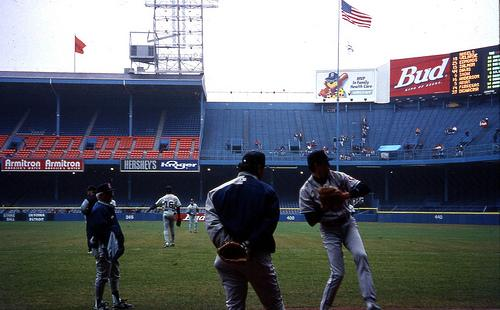What are some prominent advertisements shown in the image? Hershey's, Bud, and Armitron are some of the prominent advertisements displayed. Mention any number that appears on a player's shirt. Number 16 is visible on the back of a player's shirt. Describe the state of the grass in the image. The grass on the field appears to be green and well-kept. Identify the sports-related paraphernalia in the picture. There's a baseball glove, a baseball uniform, a baseball mitt, a baseball player, a scoreboard, and a baseball field. In one sentence, describe the general theme of the image. This image depicts a baseball game with players, spectators, and various advertisements in the stadium. Narrate a brief action one player is performing in the image. One player is wearing a glove and preparing to throw a ball. Mention the most dominant object in the image and its color. A brown leather baseball glove is the most dominant object in the image. Briefly describe the state of the sky in the image. The sky in the picture appears to be cloudy. Identify any flags visible in the image and their colors. There are American flags with red, white, and blue colors, and red flags behind the upper deck. Describe the seating arrangement and colors of the seats. The seating arrangement consists of red, blue and orange seats in the spectator stands and upper deck. 